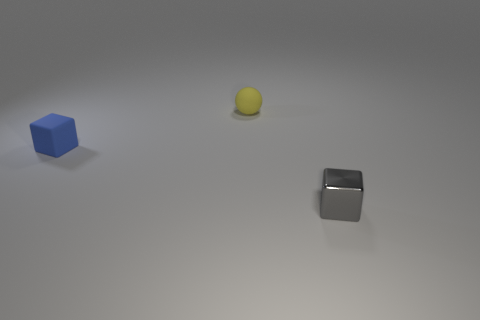Add 2 small blue blocks. How many objects exist? 5 Subtract all spheres. How many objects are left? 2 Subtract 0 cyan cylinders. How many objects are left? 3 Subtract all yellow rubber things. Subtract all rubber things. How many objects are left? 0 Add 2 small gray shiny things. How many small gray shiny things are left? 3 Add 1 gray metallic blocks. How many gray metallic blocks exist? 2 